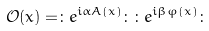Convert formula to latex. <formula><loc_0><loc_0><loc_500><loc_500>\mathcal { O } ( x ) = \colon e ^ { i \alpha A ( x ) } \colon \colon e ^ { i \beta \varphi ( x ) } \colon</formula> 